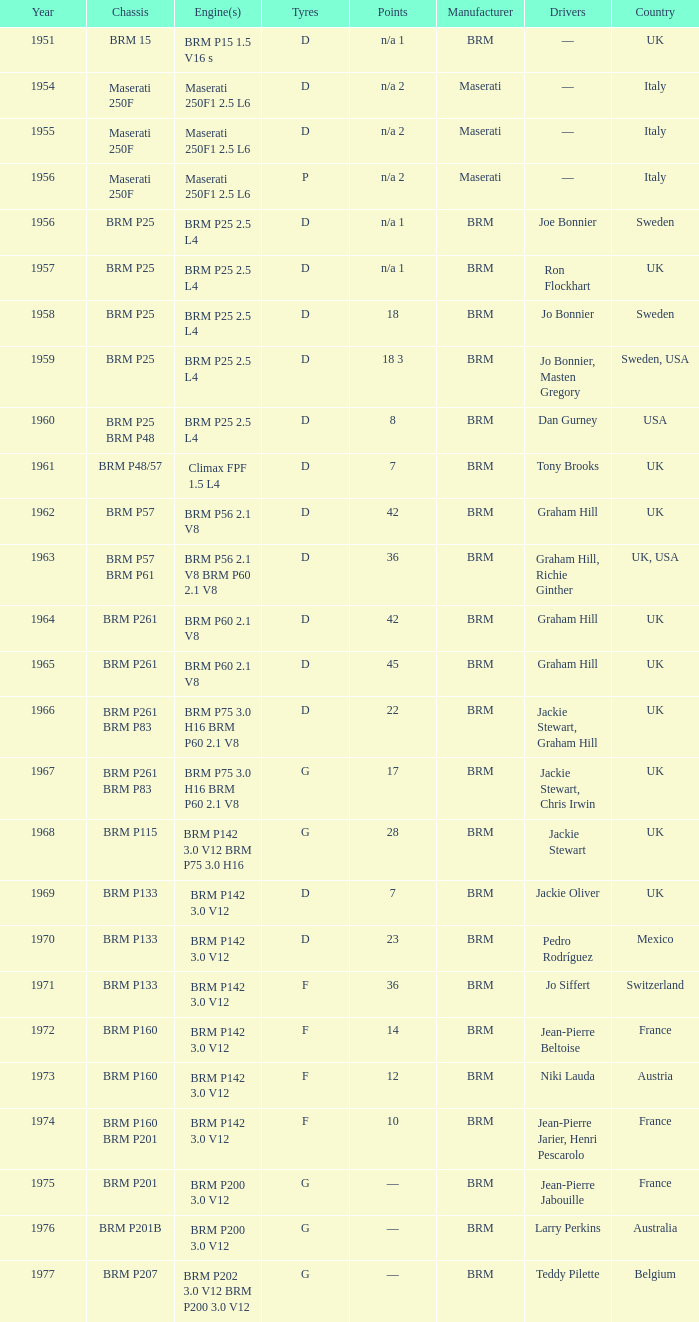What is the 1961 chassis called? BRM P48/57. 